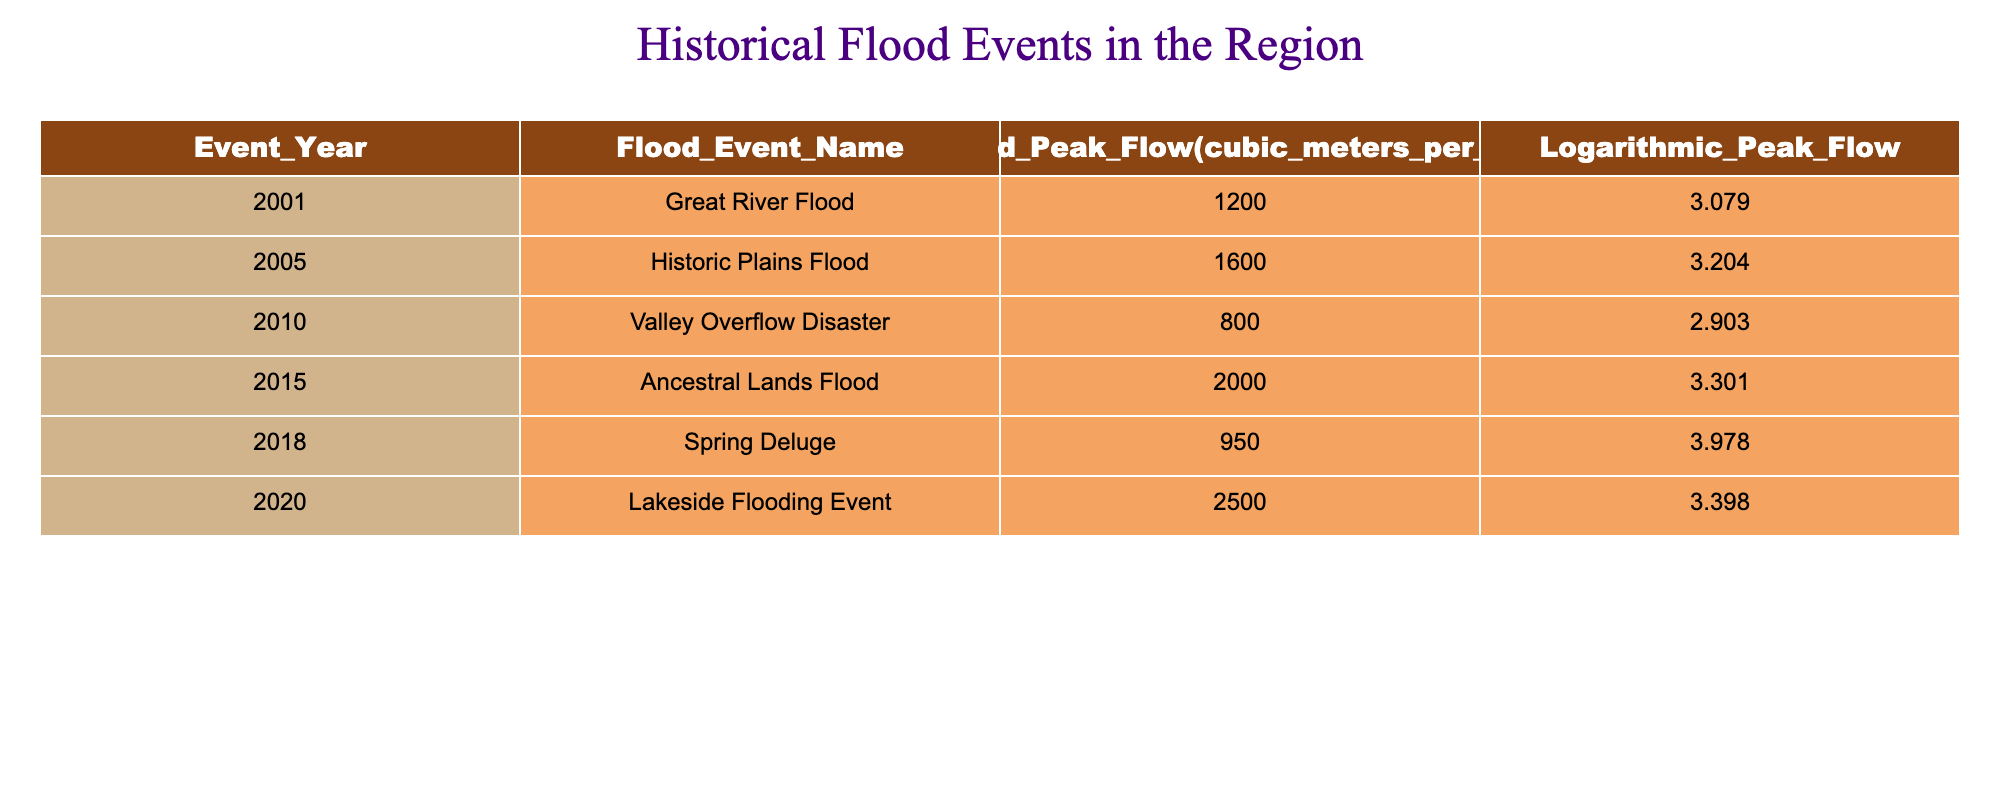What is the logarithmic peak flow of the Great River Flood? The table shows that the Great River Flood occurred in 2001 and the corresponding logarithmic peak flow is listed as 3.079.
Answer: 3.079 Which flood event had the highest expected peak flow? By comparing the values in the "Expected Peak Flow" column, the Lakeside Flooding Event has the highest expected peak flow at 2500 cubic meters per second.
Answer: Lakeside Flooding Event What is the difference in logarithmic peak flow between the Valley Overflow Disaster and the Ancestral Lands Flood? The logarithmic peak flow for the Valley Overflow Disaster is 2.903, and for the Ancestral Lands Flood, it is 3.301. The difference is 3.301 - 2.903 = 0.398.
Answer: 0.398 Is the Spring Deluge event associated with a logarithmic peak flow greater than 3.5? Looking at the logarithmic peak flow for the Spring Deluge, which is 3.978, it is indeed greater than 3.5.
Answer: Yes What was the average expected peak flow of all the flood events listed? The expected peak flows are 1200, 1600, 800, 2000, 950, and 2500. Summing these values gives 7200. Dividing by the number of events, which is 6, results in an average of 7200 / 6 = 1200.
Answer: 1200 Which flood event occurred in an odd-numbered year? The flood events in odd-numbered years are the Great River Flood (2001), Valley Overflow Disaster (2010), and Ancestral Lands Flood (2015). Therefore, there are multiple events, but one specific answer could be the Great River Flood.
Answer: Great River Flood What is the logarithmic peak flow of the most recent flood event listed? The most recent flood event in the table is the Lakeside Flooding Event from 2020. Its logarithmic peak flow is 3.398.
Answer: 3.398 How many flood events listed have a logarithmic peak flow below 3.0? The table indicates that only one event, the Valley Overflow Disaster, has a logarithmic peak flow below 3.0, which is 2.903.
Answer: 1 What is the expected peak flow for the Historic Plains Flood? The Historic Plains Flood, which took place in 2005, has an expected peak flow of 1600 cubic meters per second as indicated in the table.
Answer: 1600 